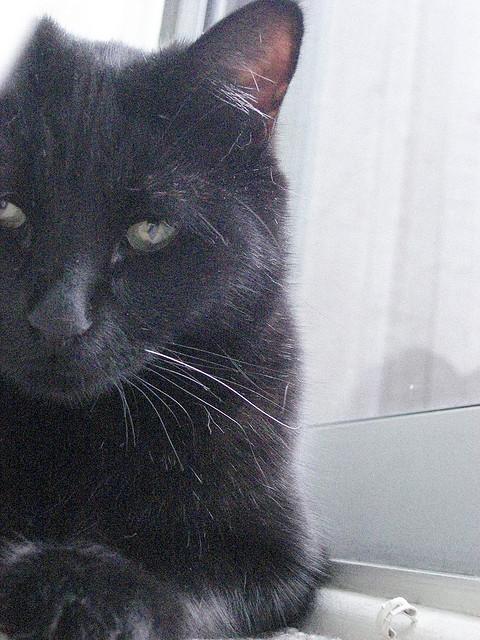Is the cat sad?
Short answer required. Yes. What color is the cat?
Quick response, please. Black. Is the cat's mouth open?
Give a very brief answer. No. 